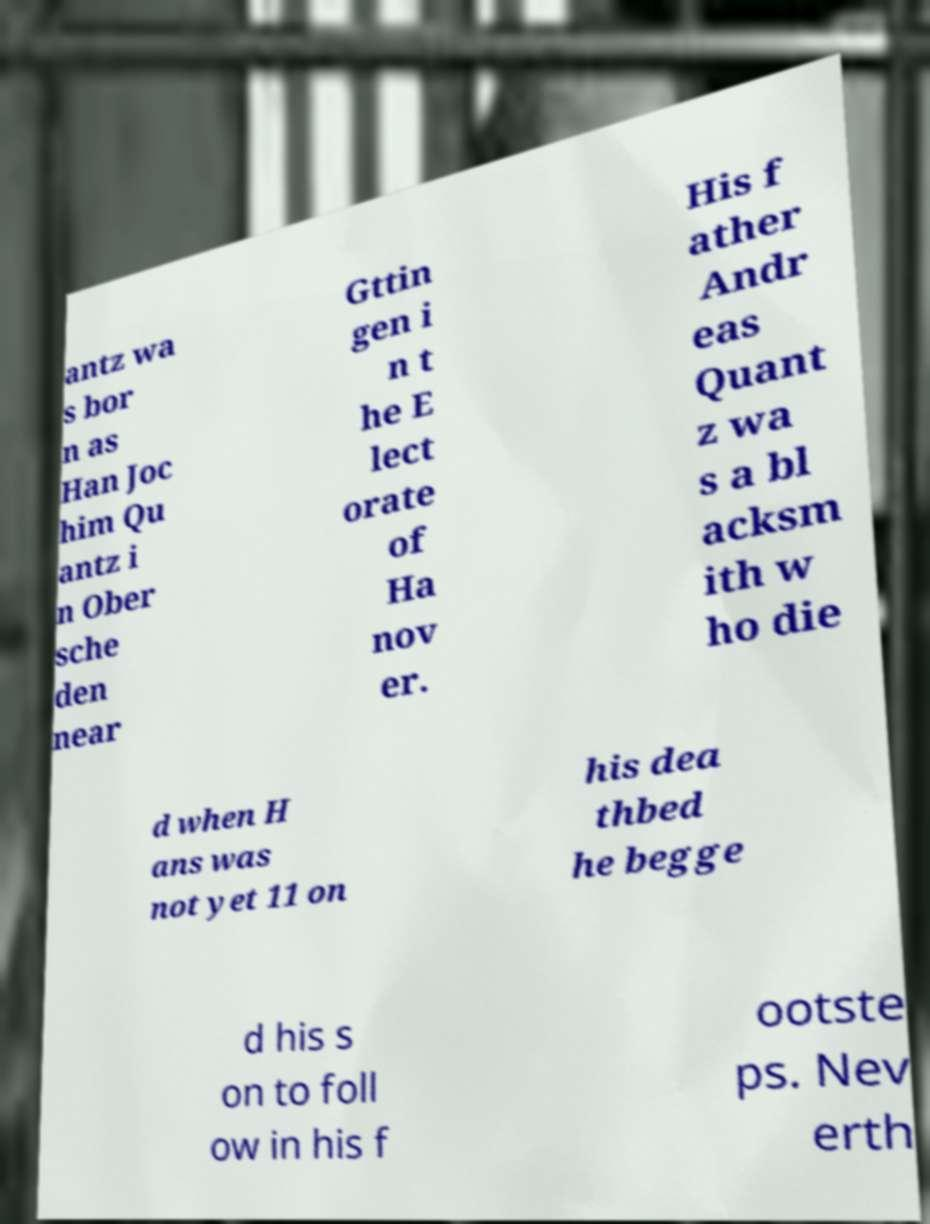Can you read and provide the text displayed in the image?This photo seems to have some interesting text. Can you extract and type it out for me? antz wa s bor n as Han Joc him Qu antz i n Ober sche den near Gttin gen i n t he E lect orate of Ha nov er. His f ather Andr eas Quant z wa s a bl acksm ith w ho die d when H ans was not yet 11 on his dea thbed he begge d his s on to foll ow in his f ootste ps. Nev erth 